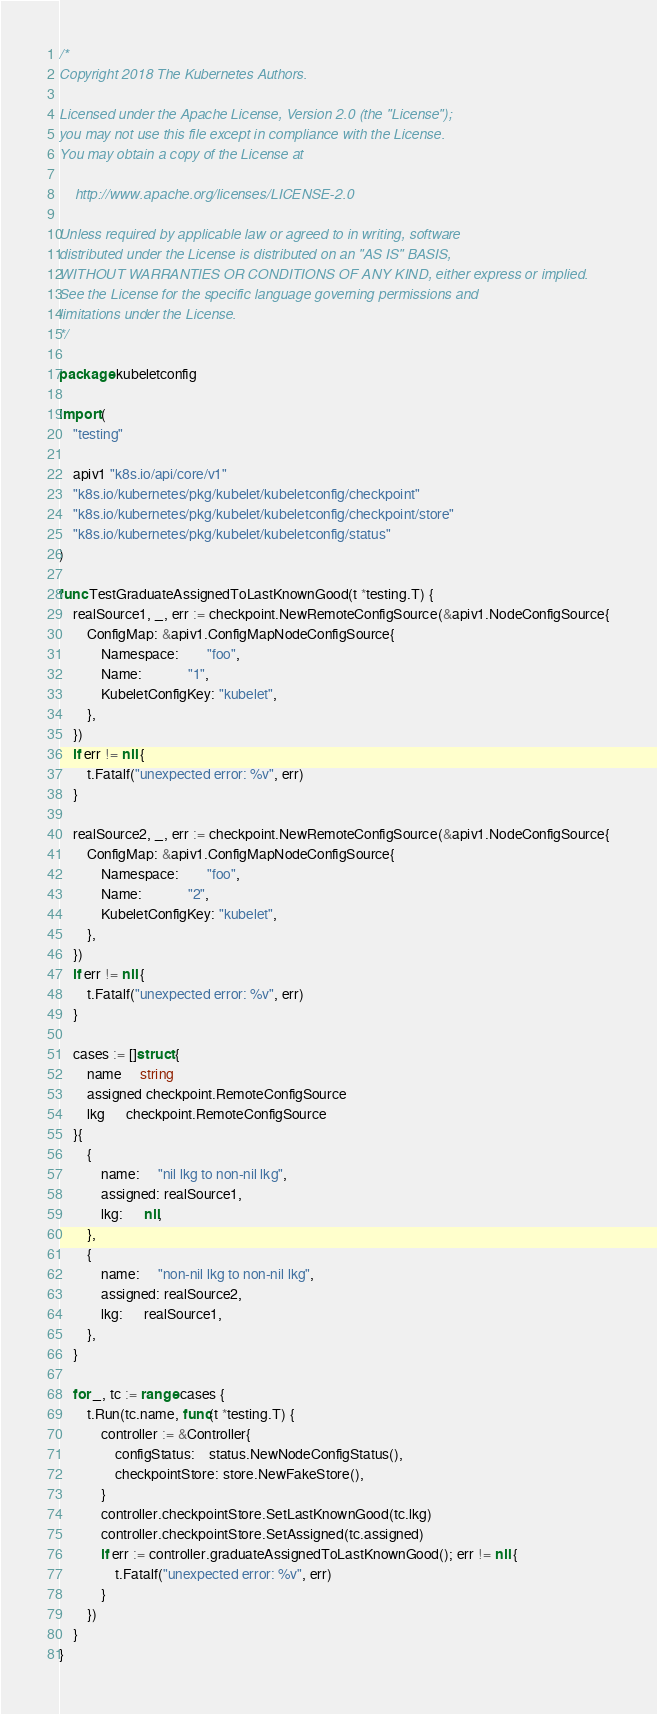Convert code to text. <code><loc_0><loc_0><loc_500><loc_500><_Go_>/*
Copyright 2018 The Kubernetes Authors.

Licensed under the Apache License, Version 2.0 (the "License");
you may not use this file except in compliance with the License.
You may obtain a copy of the License at

    http://www.apache.org/licenses/LICENSE-2.0

Unless required by applicable law or agreed to in writing, software
distributed under the License is distributed on an "AS IS" BASIS,
WITHOUT WARRANTIES OR CONDITIONS OF ANY KIND, either express or implied.
See the License for the specific language governing permissions and
limitations under the License.
*/

package kubeletconfig

import (
	"testing"

	apiv1 "k8s.io/api/core/v1"
	"k8s.io/kubernetes/pkg/kubelet/kubeletconfig/checkpoint"
	"k8s.io/kubernetes/pkg/kubelet/kubeletconfig/checkpoint/store"
	"k8s.io/kubernetes/pkg/kubelet/kubeletconfig/status"
)

func TestGraduateAssignedToLastKnownGood(t *testing.T) {
	realSource1, _, err := checkpoint.NewRemoteConfigSource(&apiv1.NodeConfigSource{
		ConfigMap: &apiv1.ConfigMapNodeConfigSource{
			Namespace:        "foo",
			Name:             "1",
			KubeletConfigKey: "kubelet",
		},
	})
	if err != nil {
		t.Fatalf("unexpected error: %v", err)
	}

	realSource2, _, err := checkpoint.NewRemoteConfigSource(&apiv1.NodeConfigSource{
		ConfigMap: &apiv1.ConfigMapNodeConfigSource{
			Namespace:        "foo",
			Name:             "2",
			KubeletConfigKey: "kubelet",
		},
	})
	if err != nil {
		t.Fatalf("unexpected error: %v", err)
	}

	cases := []struct {
		name     string
		assigned checkpoint.RemoteConfigSource
		lkg      checkpoint.RemoteConfigSource
	}{
		{
			name:     "nil lkg to non-nil lkg",
			assigned: realSource1,
			lkg:      nil,
		},
		{
			name:     "non-nil lkg to non-nil lkg",
			assigned: realSource2,
			lkg:      realSource1,
		},
	}

	for _, tc := range cases {
		t.Run(tc.name, func(t *testing.T) {
			controller := &Controller{
				configStatus:    status.NewNodeConfigStatus(),
				checkpointStore: store.NewFakeStore(),
			}
			controller.checkpointStore.SetLastKnownGood(tc.lkg)
			controller.checkpointStore.SetAssigned(tc.assigned)
			if err := controller.graduateAssignedToLastKnownGood(); err != nil {
				t.Fatalf("unexpected error: %v", err)
			}
		})
	}
}
</code> 